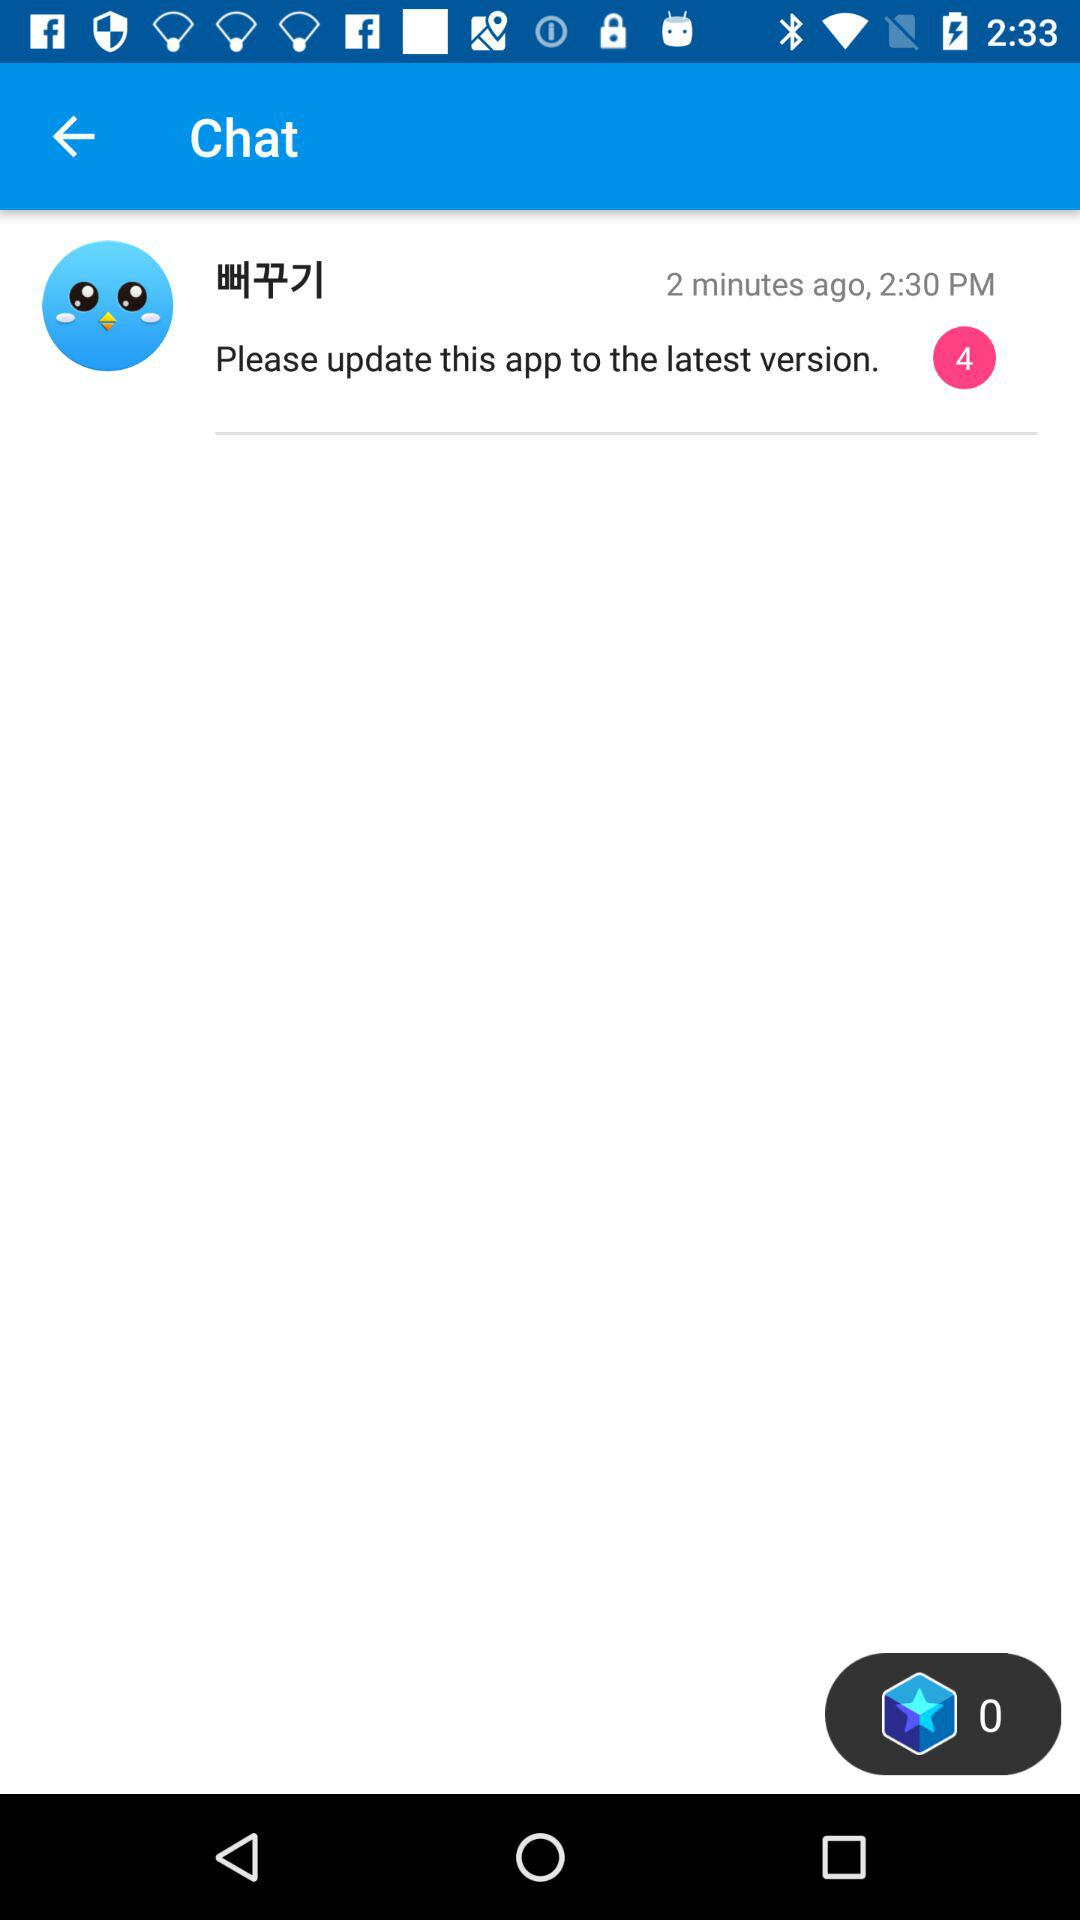How many unread messages are there? There are 4 unread messages. 